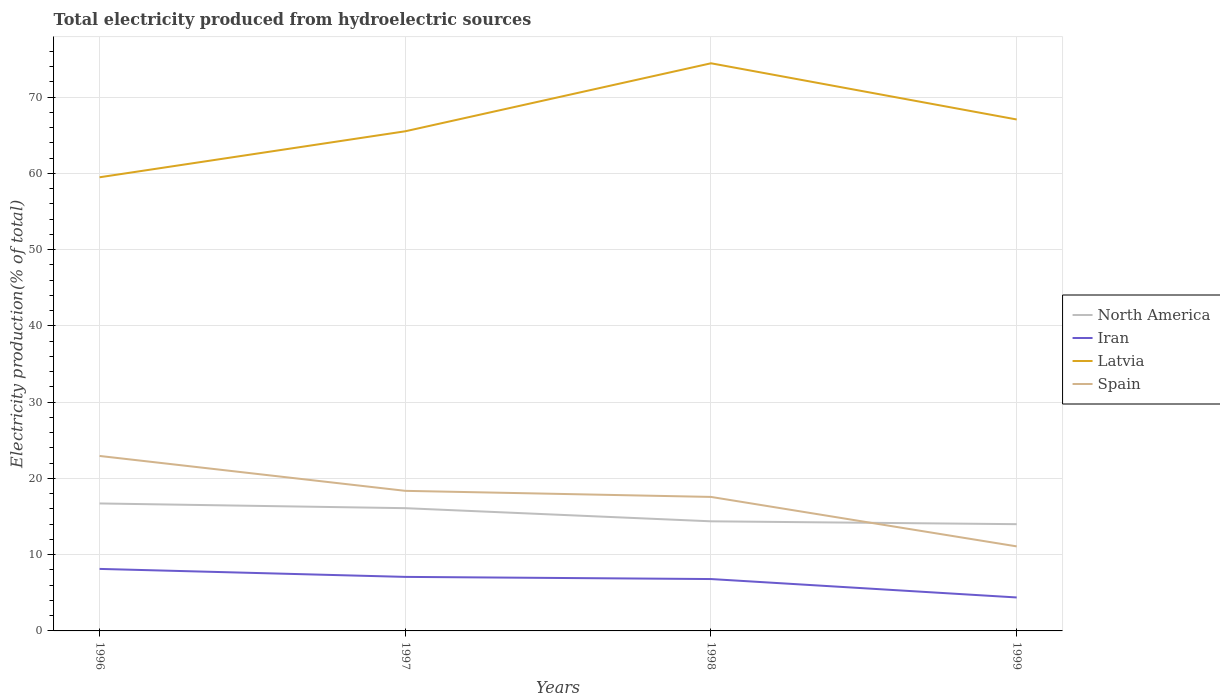Does the line corresponding to North America intersect with the line corresponding to Spain?
Provide a succinct answer. Yes. Across all years, what is the maximum total electricity produced in Latvia?
Ensure brevity in your answer.  59.5. What is the total total electricity produced in Latvia in the graph?
Give a very brief answer. -1.55. What is the difference between the highest and the second highest total electricity produced in Iran?
Offer a terse response. 3.75. Is the total electricity produced in Iran strictly greater than the total electricity produced in Spain over the years?
Ensure brevity in your answer.  Yes. What is the difference between two consecutive major ticks on the Y-axis?
Give a very brief answer. 10. Are the values on the major ticks of Y-axis written in scientific E-notation?
Offer a very short reply. No. How many legend labels are there?
Offer a terse response. 4. What is the title of the graph?
Your answer should be very brief. Total electricity produced from hydroelectric sources. What is the label or title of the Y-axis?
Offer a terse response. Electricity production(% of total). What is the Electricity production(% of total) of North America in 1996?
Offer a very short reply. 16.72. What is the Electricity production(% of total) in Iran in 1996?
Your answer should be very brief. 8.13. What is the Electricity production(% of total) in Latvia in 1996?
Offer a terse response. 59.5. What is the Electricity production(% of total) of Spain in 1996?
Make the answer very short. 22.95. What is the Electricity production(% of total) of North America in 1997?
Your response must be concise. 16.1. What is the Electricity production(% of total) in Iran in 1997?
Your answer should be very brief. 7.09. What is the Electricity production(% of total) of Latvia in 1997?
Give a very brief answer. 65.53. What is the Electricity production(% of total) of Spain in 1997?
Offer a very short reply. 18.37. What is the Electricity production(% of total) of North America in 1998?
Your answer should be compact. 14.38. What is the Electricity production(% of total) of Iran in 1998?
Your answer should be compact. 6.8. What is the Electricity production(% of total) of Latvia in 1998?
Make the answer very short. 74.45. What is the Electricity production(% of total) of Spain in 1998?
Your answer should be compact. 17.58. What is the Electricity production(% of total) in North America in 1999?
Ensure brevity in your answer.  14. What is the Electricity production(% of total) of Iran in 1999?
Offer a very short reply. 4.39. What is the Electricity production(% of total) in Latvia in 1999?
Offer a terse response. 67.08. What is the Electricity production(% of total) of Spain in 1999?
Your answer should be compact. 11.09. Across all years, what is the maximum Electricity production(% of total) of North America?
Keep it short and to the point. 16.72. Across all years, what is the maximum Electricity production(% of total) in Iran?
Your answer should be very brief. 8.13. Across all years, what is the maximum Electricity production(% of total) in Latvia?
Give a very brief answer. 74.45. Across all years, what is the maximum Electricity production(% of total) in Spain?
Keep it short and to the point. 22.95. Across all years, what is the minimum Electricity production(% of total) in North America?
Offer a very short reply. 14. Across all years, what is the minimum Electricity production(% of total) in Iran?
Provide a short and direct response. 4.39. Across all years, what is the minimum Electricity production(% of total) of Latvia?
Make the answer very short. 59.5. Across all years, what is the minimum Electricity production(% of total) in Spain?
Give a very brief answer. 11.09. What is the total Electricity production(% of total) of North America in the graph?
Provide a short and direct response. 61.2. What is the total Electricity production(% of total) in Iran in the graph?
Make the answer very short. 26.42. What is the total Electricity production(% of total) of Latvia in the graph?
Offer a very short reply. 266.57. What is the total Electricity production(% of total) of Spain in the graph?
Provide a short and direct response. 69.99. What is the difference between the Electricity production(% of total) in North America in 1996 and that in 1997?
Your answer should be very brief. 0.62. What is the difference between the Electricity production(% of total) in Iran in 1996 and that in 1997?
Keep it short and to the point. 1.05. What is the difference between the Electricity production(% of total) of Latvia in 1996 and that in 1997?
Provide a succinct answer. -6.03. What is the difference between the Electricity production(% of total) in Spain in 1996 and that in 1997?
Your answer should be compact. 4.58. What is the difference between the Electricity production(% of total) in North America in 1996 and that in 1998?
Give a very brief answer. 2.34. What is the difference between the Electricity production(% of total) in Iran in 1996 and that in 1998?
Offer a terse response. 1.33. What is the difference between the Electricity production(% of total) of Latvia in 1996 and that in 1998?
Your answer should be very brief. -14.95. What is the difference between the Electricity production(% of total) in Spain in 1996 and that in 1998?
Your answer should be compact. 5.37. What is the difference between the Electricity production(% of total) of North America in 1996 and that in 1999?
Provide a succinct answer. 2.72. What is the difference between the Electricity production(% of total) in Iran in 1996 and that in 1999?
Keep it short and to the point. 3.75. What is the difference between the Electricity production(% of total) of Latvia in 1996 and that in 1999?
Make the answer very short. -7.58. What is the difference between the Electricity production(% of total) of Spain in 1996 and that in 1999?
Keep it short and to the point. 11.86. What is the difference between the Electricity production(% of total) of North America in 1997 and that in 1998?
Keep it short and to the point. 1.72. What is the difference between the Electricity production(% of total) in Iran in 1997 and that in 1998?
Provide a short and direct response. 0.28. What is the difference between the Electricity production(% of total) of Latvia in 1997 and that in 1998?
Offer a terse response. -8.92. What is the difference between the Electricity production(% of total) in Spain in 1997 and that in 1998?
Make the answer very short. 0.8. What is the difference between the Electricity production(% of total) in North America in 1997 and that in 1999?
Ensure brevity in your answer.  2.1. What is the difference between the Electricity production(% of total) of Iran in 1997 and that in 1999?
Ensure brevity in your answer.  2.7. What is the difference between the Electricity production(% of total) of Latvia in 1997 and that in 1999?
Give a very brief answer. -1.55. What is the difference between the Electricity production(% of total) of Spain in 1997 and that in 1999?
Your response must be concise. 7.29. What is the difference between the Electricity production(% of total) in North America in 1998 and that in 1999?
Make the answer very short. 0.38. What is the difference between the Electricity production(% of total) of Iran in 1998 and that in 1999?
Provide a succinct answer. 2.42. What is the difference between the Electricity production(% of total) of Latvia in 1998 and that in 1999?
Your response must be concise. 7.37. What is the difference between the Electricity production(% of total) of Spain in 1998 and that in 1999?
Provide a short and direct response. 6.49. What is the difference between the Electricity production(% of total) in North America in 1996 and the Electricity production(% of total) in Iran in 1997?
Give a very brief answer. 9.63. What is the difference between the Electricity production(% of total) of North America in 1996 and the Electricity production(% of total) of Latvia in 1997?
Your answer should be compact. -48.81. What is the difference between the Electricity production(% of total) of North America in 1996 and the Electricity production(% of total) of Spain in 1997?
Provide a succinct answer. -1.65. What is the difference between the Electricity production(% of total) of Iran in 1996 and the Electricity production(% of total) of Latvia in 1997?
Provide a short and direct response. -57.4. What is the difference between the Electricity production(% of total) of Iran in 1996 and the Electricity production(% of total) of Spain in 1997?
Your answer should be compact. -10.24. What is the difference between the Electricity production(% of total) of Latvia in 1996 and the Electricity production(% of total) of Spain in 1997?
Make the answer very short. 41.13. What is the difference between the Electricity production(% of total) of North America in 1996 and the Electricity production(% of total) of Iran in 1998?
Keep it short and to the point. 9.92. What is the difference between the Electricity production(% of total) of North America in 1996 and the Electricity production(% of total) of Latvia in 1998?
Make the answer very short. -57.73. What is the difference between the Electricity production(% of total) of North America in 1996 and the Electricity production(% of total) of Spain in 1998?
Offer a terse response. -0.86. What is the difference between the Electricity production(% of total) of Iran in 1996 and the Electricity production(% of total) of Latvia in 1998?
Keep it short and to the point. -66.32. What is the difference between the Electricity production(% of total) in Iran in 1996 and the Electricity production(% of total) in Spain in 1998?
Make the answer very short. -9.44. What is the difference between the Electricity production(% of total) in Latvia in 1996 and the Electricity production(% of total) in Spain in 1998?
Your response must be concise. 41.93. What is the difference between the Electricity production(% of total) of North America in 1996 and the Electricity production(% of total) of Iran in 1999?
Ensure brevity in your answer.  12.33. What is the difference between the Electricity production(% of total) in North America in 1996 and the Electricity production(% of total) in Latvia in 1999?
Your answer should be very brief. -50.36. What is the difference between the Electricity production(% of total) of North America in 1996 and the Electricity production(% of total) of Spain in 1999?
Your answer should be very brief. 5.63. What is the difference between the Electricity production(% of total) in Iran in 1996 and the Electricity production(% of total) in Latvia in 1999?
Offer a very short reply. -58.95. What is the difference between the Electricity production(% of total) in Iran in 1996 and the Electricity production(% of total) in Spain in 1999?
Your answer should be compact. -2.95. What is the difference between the Electricity production(% of total) in Latvia in 1996 and the Electricity production(% of total) in Spain in 1999?
Your answer should be very brief. 48.41. What is the difference between the Electricity production(% of total) of North America in 1997 and the Electricity production(% of total) of Iran in 1998?
Offer a very short reply. 9.3. What is the difference between the Electricity production(% of total) of North America in 1997 and the Electricity production(% of total) of Latvia in 1998?
Provide a succinct answer. -58.35. What is the difference between the Electricity production(% of total) of North America in 1997 and the Electricity production(% of total) of Spain in 1998?
Your answer should be compact. -1.47. What is the difference between the Electricity production(% of total) of Iran in 1997 and the Electricity production(% of total) of Latvia in 1998?
Make the answer very short. -67.36. What is the difference between the Electricity production(% of total) in Iran in 1997 and the Electricity production(% of total) in Spain in 1998?
Provide a short and direct response. -10.49. What is the difference between the Electricity production(% of total) in Latvia in 1997 and the Electricity production(% of total) in Spain in 1998?
Offer a terse response. 47.96. What is the difference between the Electricity production(% of total) in North America in 1997 and the Electricity production(% of total) in Iran in 1999?
Offer a terse response. 11.71. What is the difference between the Electricity production(% of total) in North America in 1997 and the Electricity production(% of total) in Latvia in 1999?
Keep it short and to the point. -50.98. What is the difference between the Electricity production(% of total) in North America in 1997 and the Electricity production(% of total) in Spain in 1999?
Provide a succinct answer. 5.01. What is the difference between the Electricity production(% of total) of Iran in 1997 and the Electricity production(% of total) of Latvia in 1999?
Keep it short and to the point. -59.99. What is the difference between the Electricity production(% of total) of Iran in 1997 and the Electricity production(% of total) of Spain in 1999?
Offer a very short reply. -4. What is the difference between the Electricity production(% of total) in Latvia in 1997 and the Electricity production(% of total) in Spain in 1999?
Offer a very short reply. 54.45. What is the difference between the Electricity production(% of total) of North America in 1998 and the Electricity production(% of total) of Iran in 1999?
Provide a short and direct response. 9.99. What is the difference between the Electricity production(% of total) of North America in 1998 and the Electricity production(% of total) of Latvia in 1999?
Make the answer very short. -52.7. What is the difference between the Electricity production(% of total) in North America in 1998 and the Electricity production(% of total) in Spain in 1999?
Offer a terse response. 3.29. What is the difference between the Electricity production(% of total) in Iran in 1998 and the Electricity production(% of total) in Latvia in 1999?
Offer a terse response. -60.28. What is the difference between the Electricity production(% of total) in Iran in 1998 and the Electricity production(% of total) in Spain in 1999?
Give a very brief answer. -4.28. What is the difference between the Electricity production(% of total) of Latvia in 1998 and the Electricity production(% of total) of Spain in 1999?
Ensure brevity in your answer.  63.36. What is the average Electricity production(% of total) of North America per year?
Provide a succinct answer. 15.3. What is the average Electricity production(% of total) in Iran per year?
Provide a succinct answer. 6.6. What is the average Electricity production(% of total) of Latvia per year?
Offer a terse response. 66.64. What is the average Electricity production(% of total) of Spain per year?
Your answer should be very brief. 17.5. In the year 1996, what is the difference between the Electricity production(% of total) of North America and Electricity production(% of total) of Iran?
Provide a short and direct response. 8.58. In the year 1996, what is the difference between the Electricity production(% of total) of North America and Electricity production(% of total) of Latvia?
Ensure brevity in your answer.  -42.78. In the year 1996, what is the difference between the Electricity production(% of total) in North America and Electricity production(% of total) in Spain?
Your answer should be very brief. -6.23. In the year 1996, what is the difference between the Electricity production(% of total) of Iran and Electricity production(% of total) of Latvia?
Provide a succinct answer. -51.37. In the year 1996, what is the difference between the Electricity production(% of total) in Iran and Electricity production(% of total) in Spain?
Make the answer very short. -14.81. In the year 1996, what is the difference between the Electricity production(% of total) of Latvia and Electricity production(% of total) of Spain?
Provide a succinct answer. 36.55. In the year 1997, what is the difference between the Electricity production(% of total) in North America and Electricity production(% of total) in Iran?
Provide a short and direct response. 9.01. In the year 1997, what is the difference between the Electricity production(% of total) in North America and Electricity production(% of total) in Latvia?
Your response must be concise. -49.43. In the year 1997, what is the difference between the Electricity production(% of total) of North America and Electricity production(% of total) of Spain?
Provide a short and direct response. -2.27. In the year 1997, what is the difference between the Electricity production(% of total) of Iran and Electricity production(% of total) of Latvia?
Your answer should be compact. -58.45. In the year 1997, what is the difference between the Electricity production(% of total) in Iran and Electricity production(% of total) in Spain?
Your response must be concise. -11.29. In the year 1997, what is the difference between the Electricity production(% of total) of Latvia and Electricity production(% of total) of Spain?
Offer a terse response. 47.16. In the year 1998, what is the difference between the Electricity production(% of total) of North America and Electricity production(% of total) of Iran?
Offer a very short reply. 7.57. In the year 1998, what is the difference between the Electricity production(% of total) in North America and Electricity production(% of total) in Latvia?
Your response must be concise. -60.08. In the year 1998, what is the difference between the Electricity production(% of total) of North America and Electricity production(% of total) of Spain?
Keep it short and to the point. -3.2. In the year 1998, what is the difference between the Electricity production(% of total) of Iran and Electricity production(% of total) of Latvia?
Provide a short and direct response. -67.65. In the year 1998, what is the difference between the Electricity production(% of total) in Iran and Electricity production(% of total) in Spain?
Ensure brevity in your answer.  -10.77. In the year 1998, what is the difference between the Electricity production(% of total) of Latvia and Electricity production(% of total) of Spain?
Provide a succinct answer. 56.88. In the year 1999, what is the difference between the Electricity production(% of total) of North America and Electricity production(% of total) of Iran?
Offer a terse response. 9.61. In the year 1999, what is the difference between the Electricity production(% of total) in North America and Electricity production(% of total) in Latvia?
Your response must be concise. -53.08. In the year 1999, what is the difference between the Electricity production(% of total) in North America and Electricity production(% of total) in Spain?
Make the answer very short. 2.91. In the year 1999, what is the difference between the Electricity production(% of total) of Iran and Electricity production(% of total) of Latvia?
Your response must be concise. -62.69. In the year 1999, what is the difference between the Electricity production(% of total) in Iran and Electricity production(% of total) in Spain?
Make the answer very short. -6.7. In the year 1999, what is the difference between the Electricity production(% of total) in Latvia and Electricity production(% of total) in Spain?
Your answer should be very brief. 55.99. What is the ratio of the Electricity production(% of total) in Iran in 1996 to that in 1997?
Provide a short and direct response. 1.15. What is the ratio of the Electricity production(% of total) in Latvia in 1996 to that in 1997?
Make the answer very short. 0.91. What is the ratio of the Electricity production(% of total) of Spain in 1996 to that in 1997?
Your response must be concise. 1.25. What is the ratio of the Electricity production(% of total) in North America in 1996 to that in 1998?
Offer a very short reply. 1.16. What is the ratio of the Electricity production(% of total) of Iran in 1996 to that in 1998?
Offer a very short reply. 1.2. What is the ratio of the Electricity production(% of total) in Latvia in 1996 to that in 1998?
Provide a short and direct response. 0.8. What is the ratio of the Electricity production(% of total) in Spain in 1996 to that in 1998?
Your answer should be very brief. 1.31. What is the ratio of the Electricity production(% of total) in North America in 1996 to that in 1999?
Make the answer very short. 1.19. What is the ratio of the Electricity production(% of total) of Iran in 1996 to that in 1999?
Give a very brief answer. 1.85. What is the ratio of the Electricity production(% of total) in Latvia in 1996 to that in 1999?
Make the answer very short. 0.89. What is the ratio of the Electricity production(% of total) in Spain in 1996 to that in 1999?
Offer a very short reply. 2.07. What is the ratio of the Electricity production(% of total) of North America in 1997 to that in 1998?
Make the answer very short. 1.12. What is the ratio of the Electricity production(% of total) in Iran in 1997 to that in 1998?
Offer a very short reply. 1.04. What is the ratio of the Electricity production(% of total) in Latvia in 1997 to that in 1998?
Your answer should be compact. 0.88. What is the ratio of the Electricity production(% of total) of Spain in 1997 to that in 1998?
Your response must be concise. 1.05. What is the ratio of the Electricity production(% of total) in North America in 1997 to that in 1999?
Provide a succinct answer. 1.15. What is the ratio of the Electricity production(% of total) of Iran in 1997 to that in 1999?
Ensure brevity in your answer.  1.61. What is the ratio of the Electricity production(% of total) in Spain in 1997 to that in 1999?
Offer a very short reply. 1.66. What is the ratio of the Electricity production(% of total) of North America in 1998 to that in 1999?
Give a very brief answer. 1.03. What is the ratio of the Electricity production(% of total) in Iran in 1998 to that in 1999?
Offer a very short reply. 1.55. What is the ratio of the Electricity production(% of total) of Latvia in 1998 to that in 1999?
Your answer should be very brief. 1.11. What is the ratio of the Electricity production(% of total) in Spain in 1998 to that in 1999?
Offer a very short reply. 1.59. What is the difference between the highest and the second highest Electricity production(% of total) in North America?
Provide a short and direct response. 0.62. What is the difference between the highest and the second highest Electricity production(% of total) of Iran?
Provide a succinct answer. 1.05. What is the difference between the highest and the second highest Electricity production(% of total) of Latvia?
Your answer should be very brief. 7.37. What is the difference between the highest and the second highest Electricity production(% of total) in Spain?
Provide a short and direct response. 4.58. What is the difference between the highest and the lowest Electricity production(% of total) of North America?
Give a very brief answer. 2.72. What is the difference between the highest and the lowest Electricity production(% of total) in Iran?
Your response must be concise. 3.75. What is the difference between the highest and the lowest Electricity production(% of total) in Latvia?
Keep it short and to the point. 14.95. What is the difference between the highest and the lowest Electricity production(% of total) in Spain?
Your response must be concise. 11.86. 